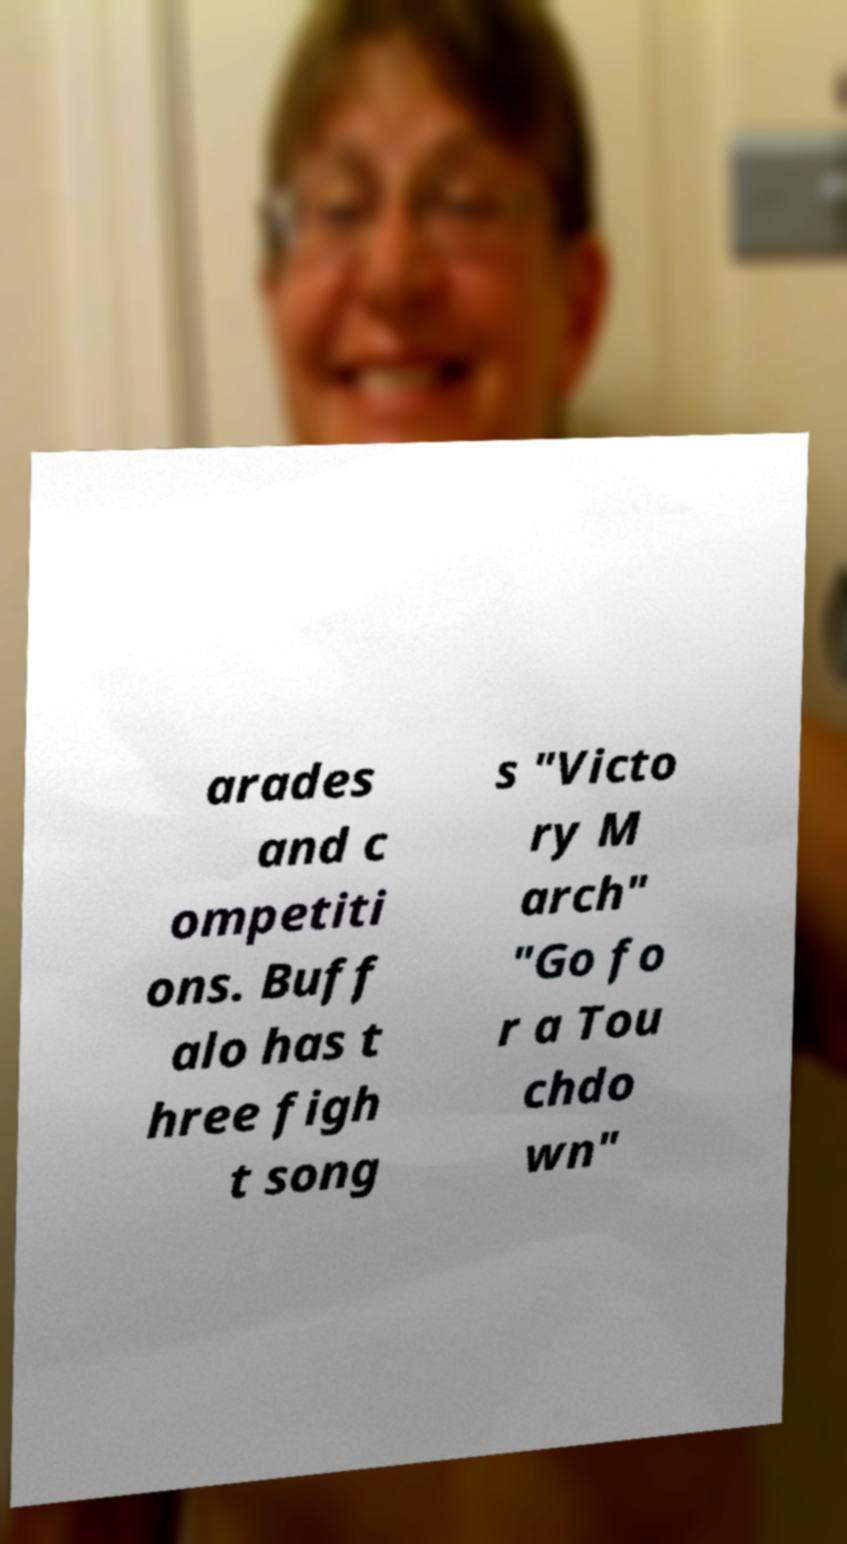Please identify and transcribe the text found in this image. arades and c ompetiti ons. Buff alo has t hree figh t song s "Victo ry M arch" "Go fo r a Tou chdo wn" 